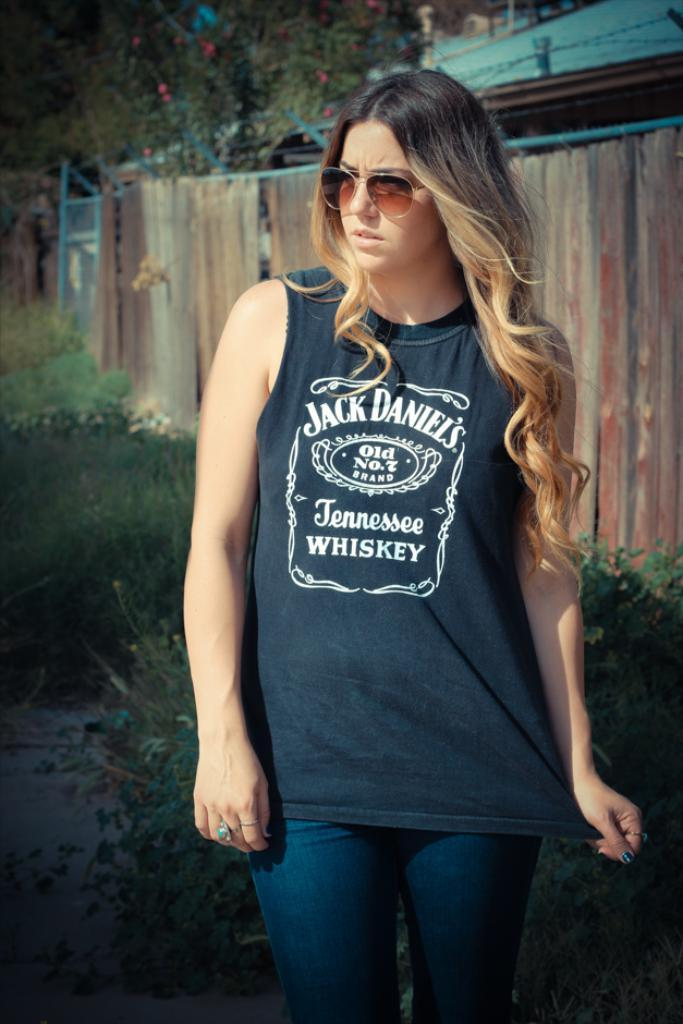Who is the main subject in the image? There is a woman standing in the center of the image. What can be seen in the background of the image? There are houses, trees, and plants in the background of the image. What type of mitten is the woman wearing in the image? The woman is not wearing a mitten in the image; she is not wearing any gloves or mittens. Can you see a kettle in the image? There is no kettle present in the image. 